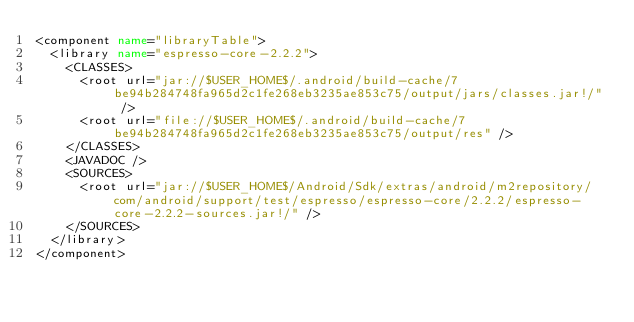Convert code to text. <code><loc_0><loc_0><loc_500><loc_500><_XML_><component name="libraryTable">
  <library name="espresso-core-2.2.2">
    <CLASSES>
      <root url="jar://$USER_HOME$/.android/build-cache/7be94b284748fa965d2c1fe268eb3235ae853c75/output/jars/classes.jar!/" />
      <root url="file://$USER_HOME$/.android/build-cache/7be94b284748fa965d2c1fe268eb3235ae853c75/output/res" />
    </CLASSES>
    <JAVADOC />
    <SOURCES>
      <root url="jar://$USER_HOME$/Android/Sdk/extras/android/m2repository/com/android/support/test/espresso/espresso-core/2.2.2/espresso-core-2.2.2-sources.jar!/" />
    </SOURCES>
  </library>
</component></code> 